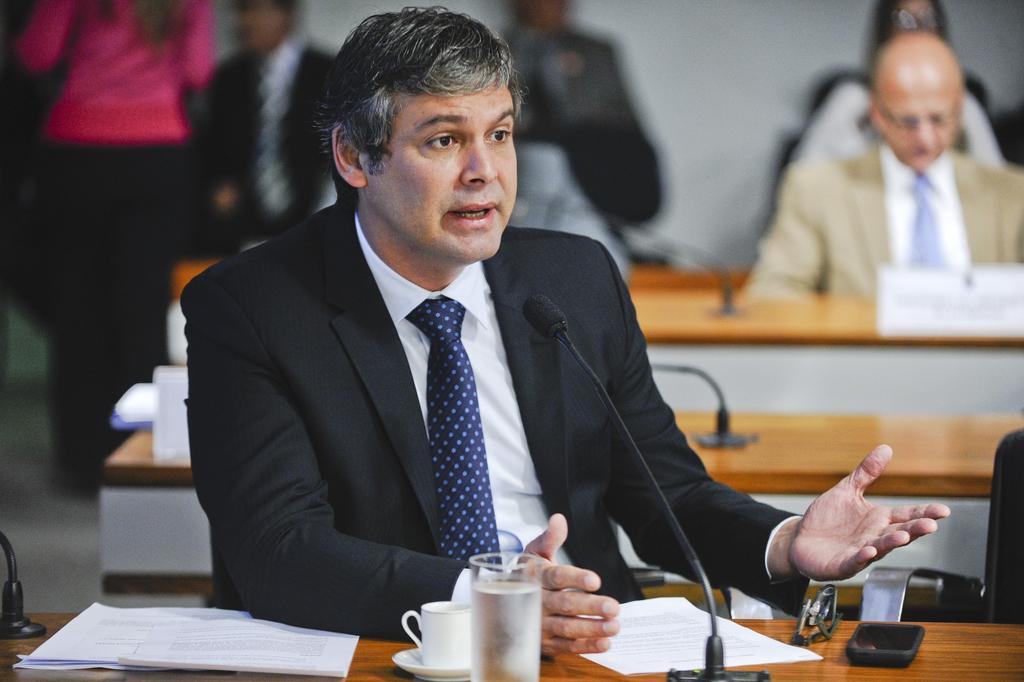Can you describe this image briefly? In this image we can see a person wearing blazer and tie is sitting on the chair near the table where papers, cup, saucer, glass with water, mix, spectacles and mobile phone and kept on the wooden table. The background of the image is slightly blurred, where we can see a few more people sitting on the chairs near the table and a person wearing pink dress is standing on the floor. 